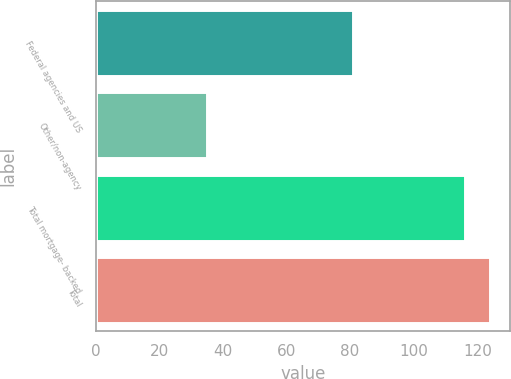Convert chart to OTSL. <chart><loc_0><loc_0><loc_500><loc_500><bar_chart><fcel>Federal agencies and US<fcel>Other/non-agency<fcel>Total mortgage- backed<fcel>Total<nl><fcel>81<fcel>35<fcel>116<fcel>124.1<nl></chart> 